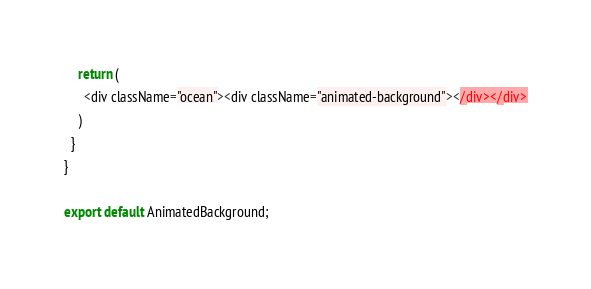<code> <loc_0><loc_0><loc_500><loc_500><_JavaScript_>    return (
      <div className="ocean"><div className="animated-background"></div></div>
    )
  }
}

export default AnimatedBackground;
</code> 